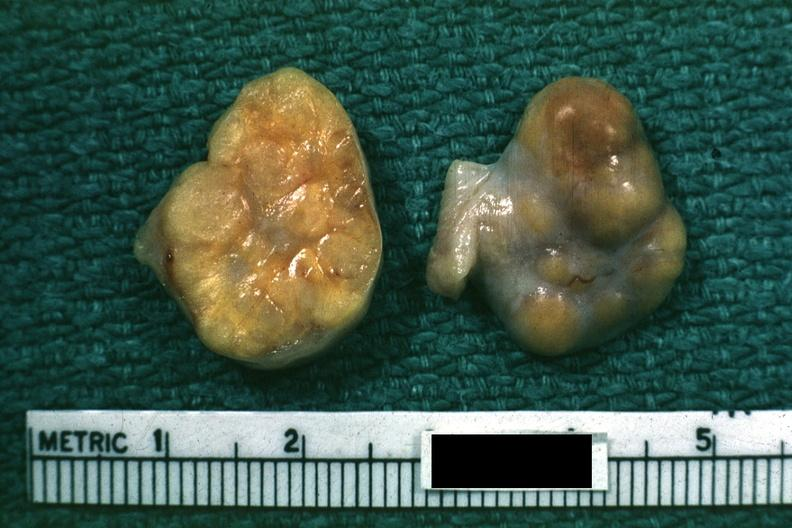where does this belong to?
Answer the question using a single word or phrase. Female reproductive system 